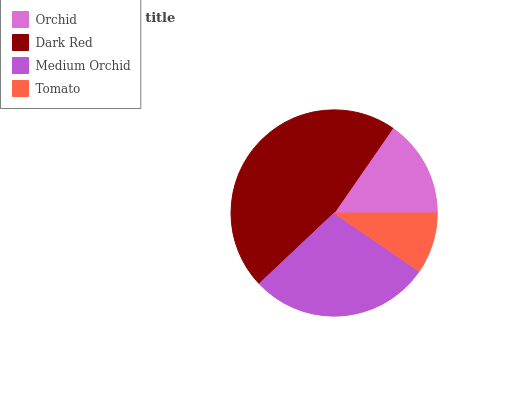Is Tomato the minimum?
Answer yes or no. Yes. Is Dark Red the maximum?
Answer yes or no. Yes. Is Medium Orchid the minimum?
Answer yes or no. No. Is Medium Orchid the maximum?
Answer yes or no. No. Is Dark Red greater than Medium Orchid?
Answer yes or no. Yes. Is Medium Orchid less than Dark Red?
Answer yes or no. Yes. Is Medium Orchid greater than Dark Red?
Answer yes or no. No. Is Dark Red less than Medium Orchid?
Answer yes or no. No. Is Medium Orchid the high median?
Answer yes or no. Yes. Is Orchid the low median?
Answer yes or no. Yes. Is Dark Red the high median?
Answer yes or no. No. Is Dark Red the low median?
Answer yes or no. No. 